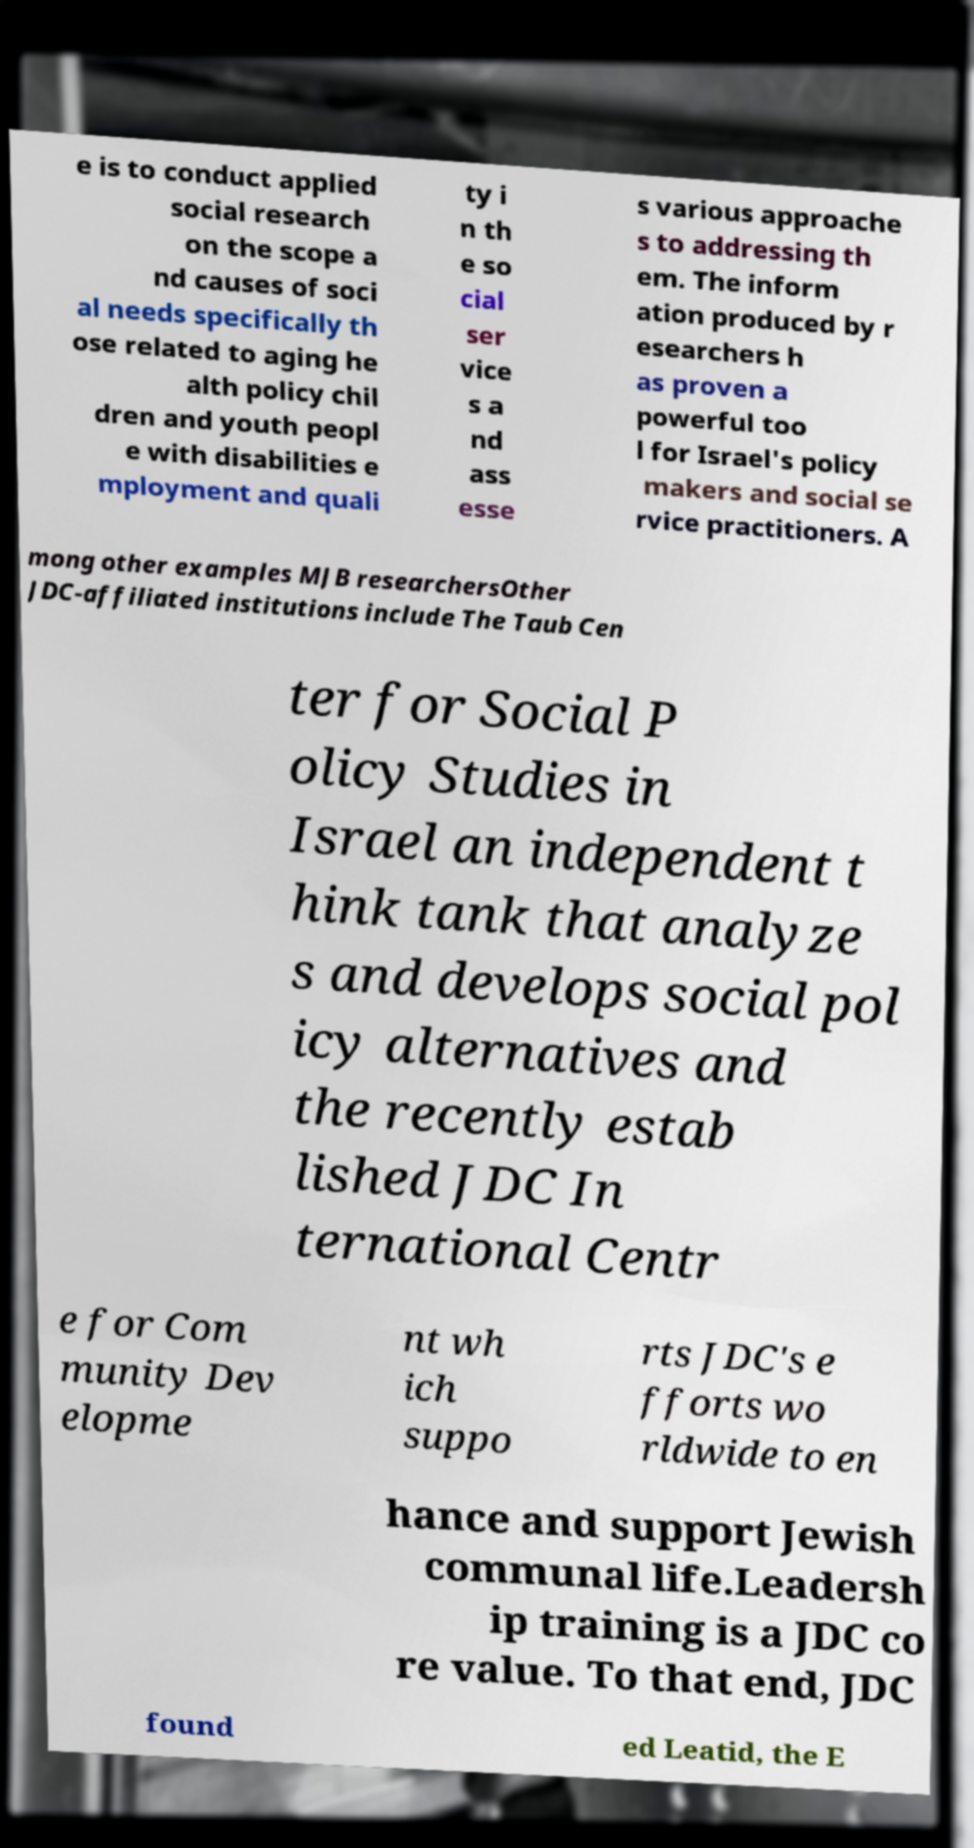There's text embedded in this image that I need extracted. Can you transcribe it verbatim? e is to conduct applied social research on the scope a nd causes of soci al needs specifically th ose related to aging he alth policy chil dren and youth peopl e with disabilities e mployment and quali ty i n th e so cial ser vice s a nd ass esse s various approache s to addressing th em. The inform ation produced by r esearchers h as proven a powerful too l for Israel's policy makers and social se rvice practitioners. A mong other examples MJB researchersOther JDC-affiliated institutions include The Taub Cen ter for Social P olicy Studies in Israel an independent t hink tank that analyze s and develops social pol icy alternatives and the recently estab lished JDC In ternational Centr e for Com munity Dev elopme nt wh ich suppo rts JDC's e fforts wo rldwide to en hance and support Jewish communal life.Leadersh ip training is a JDC co re value. To that end, JDC found ed Leatid, the E 